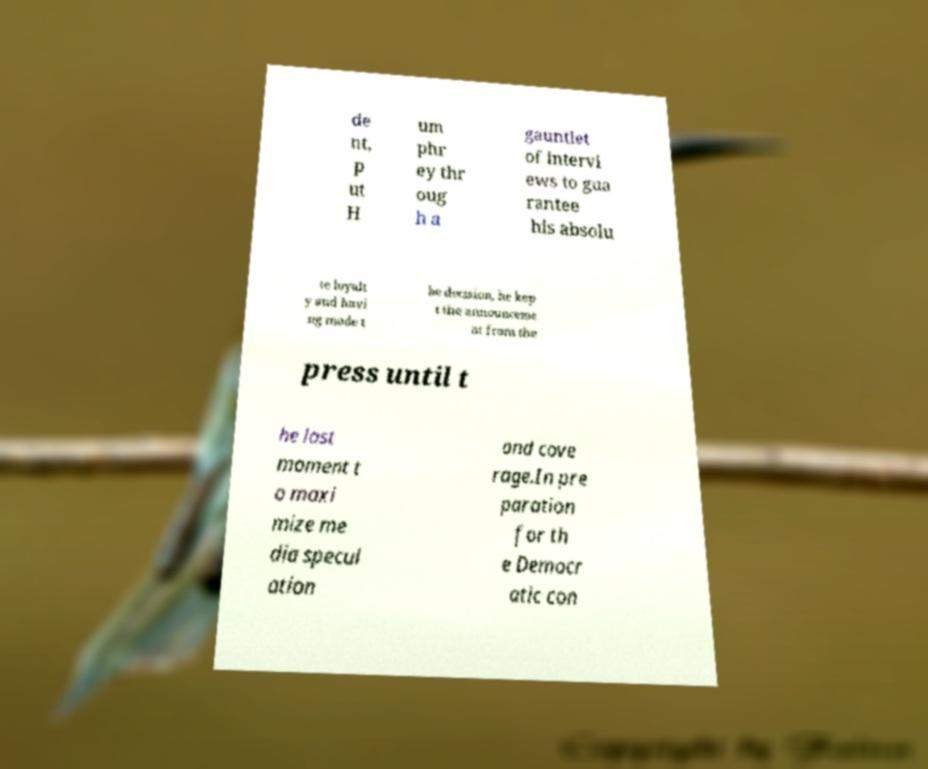Please read and relay the text visible in this image. What does it say? de nt, p ut H um phr ey thr oug h a gauntlet of intervi ews to gua rantee his absolu te loyalt y and havi ng made t he decision, he kep t the announceme nt from the press until t he last moment t o maxi mize me dia specul ation and cove rage.In pre paration for th e Democr atic con 